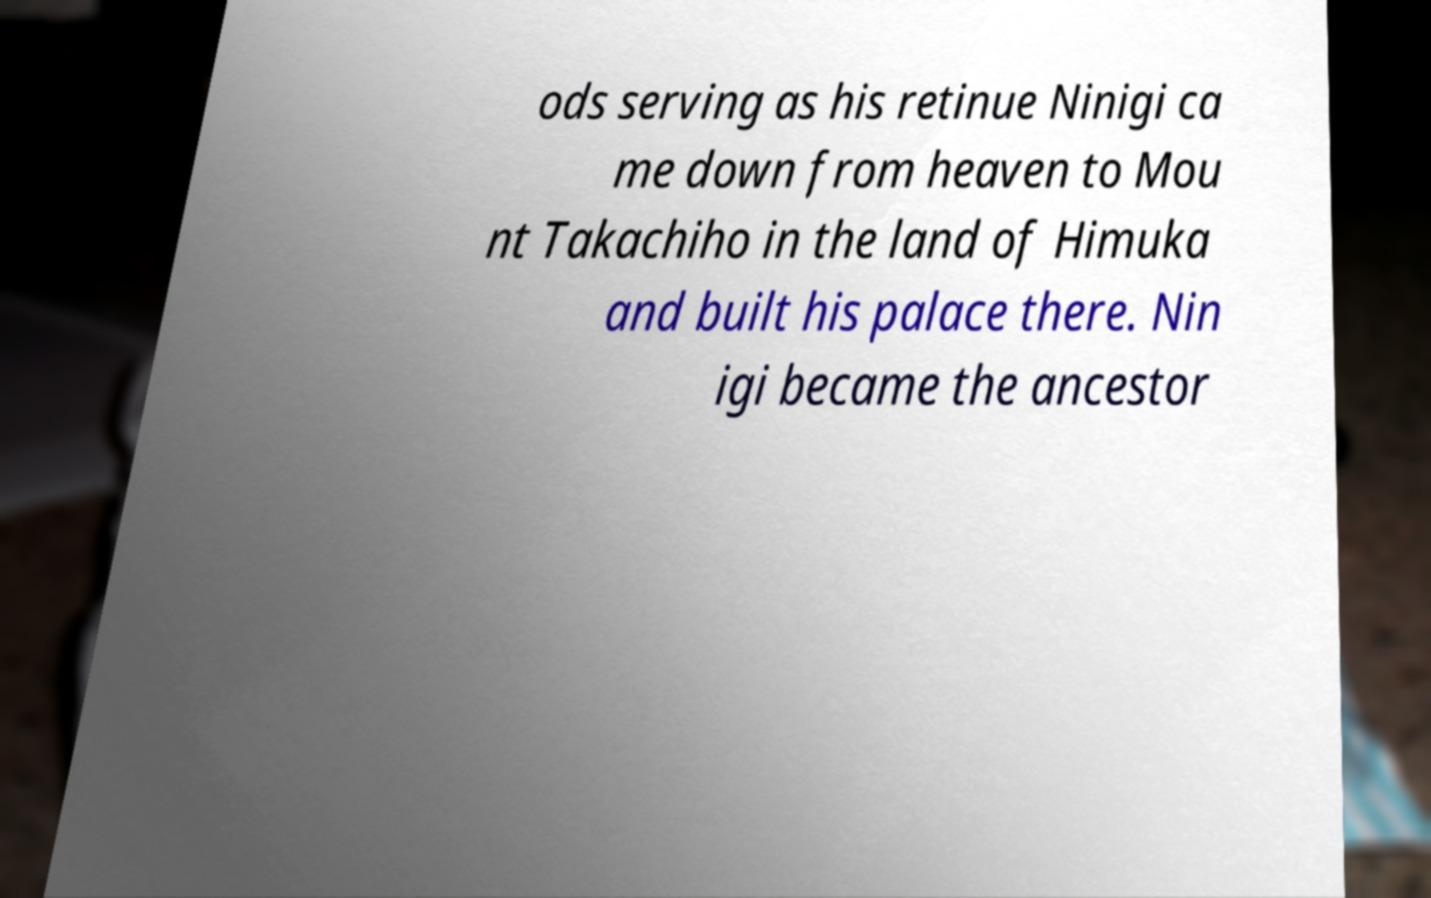Please read and relay the text visible in this image. What does it say? ods serving as his retinue Ninigi ca me down from heaven to Mou nt Takachiho in the land of Himuka and built his palace there. Nin igi became the ancestor 